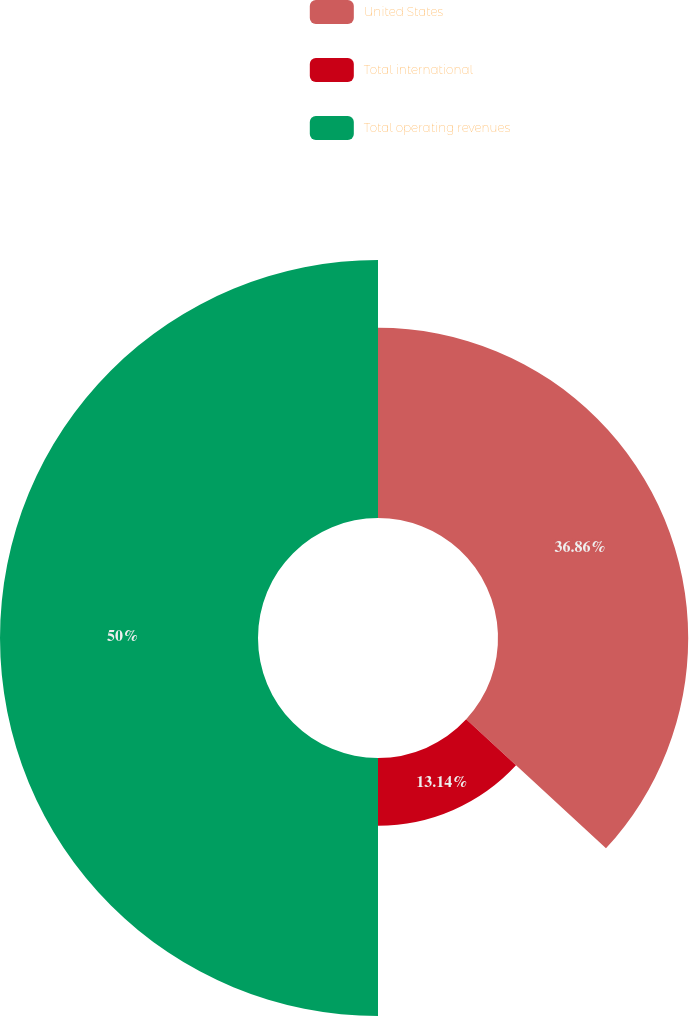<chart> <loc_0><loc_0><loc_500><loc_500><pie_chart><fcel>United States<fcel>Total international<fcel>Total operating revenues<nl><fcel>36.86%<fcel>13.14%<fcel>50.0%<nl></chart> 